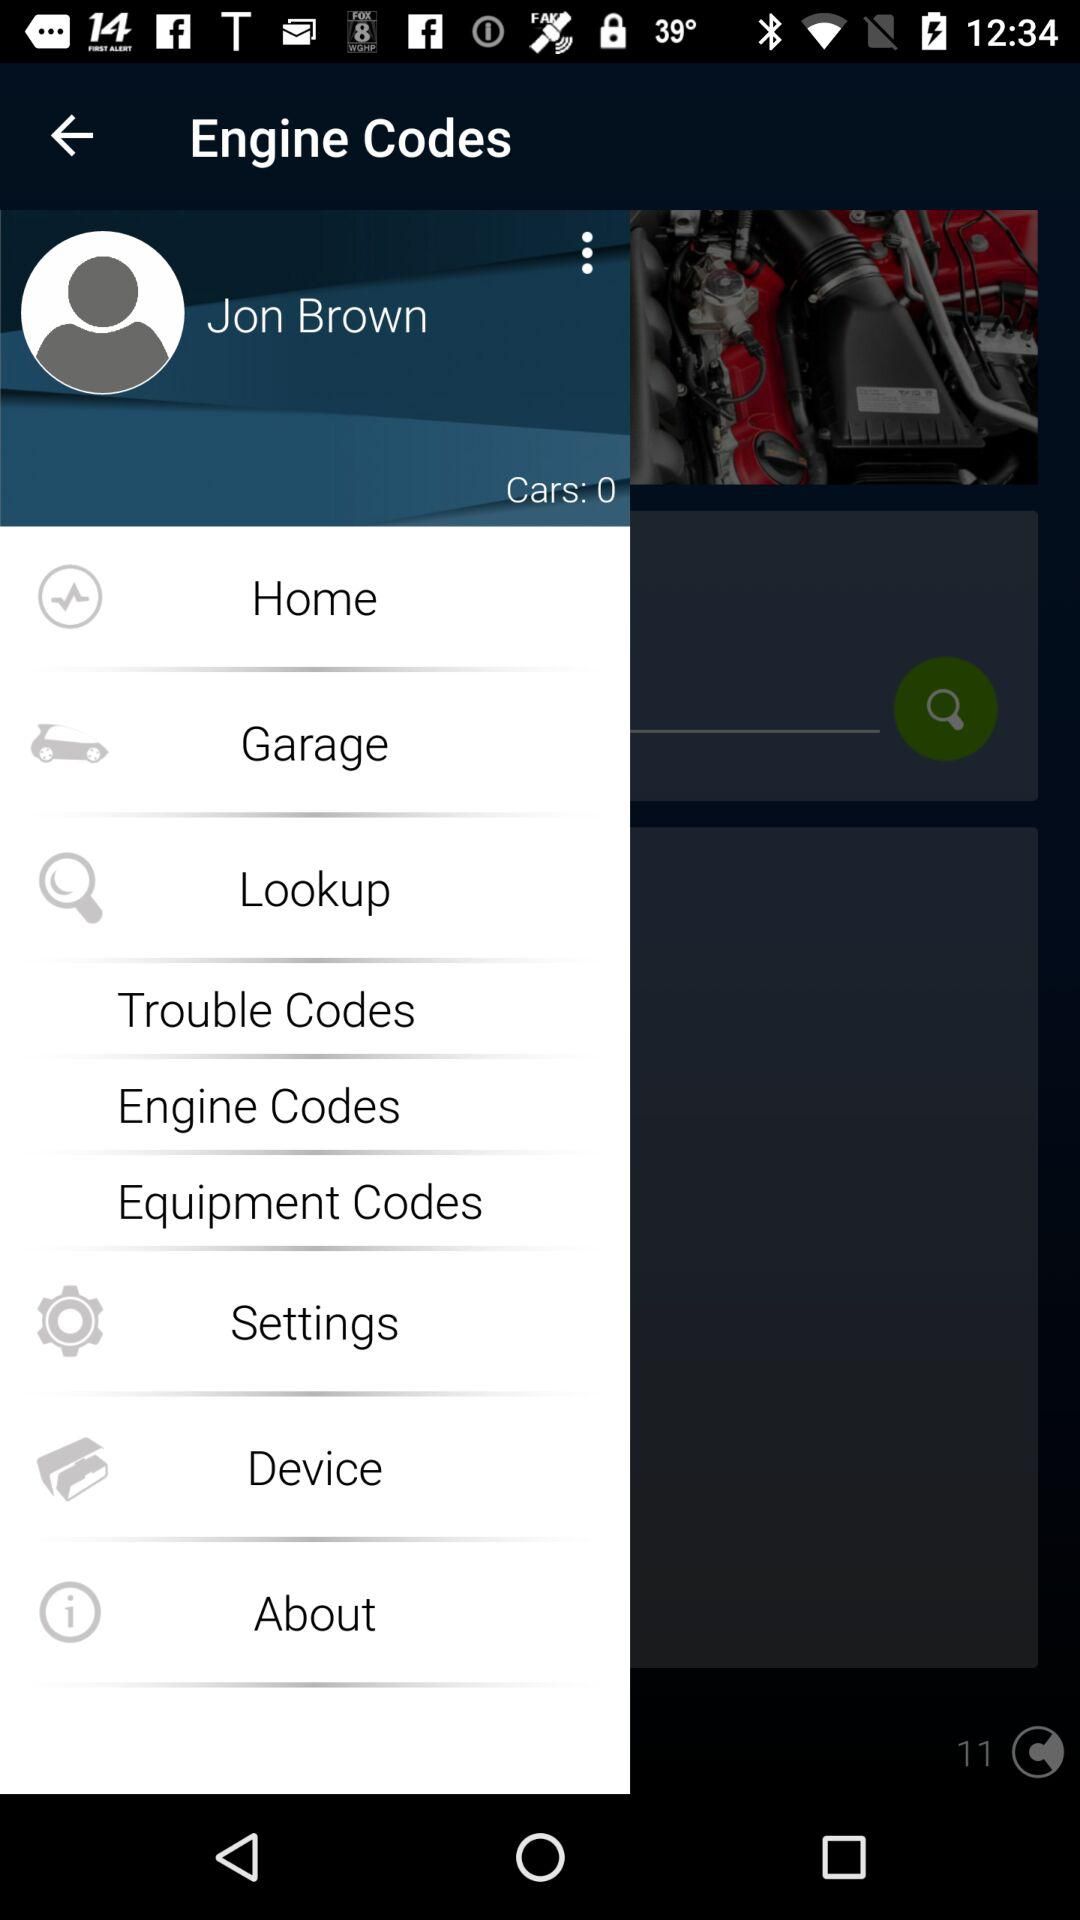What are the different types of codes given on the screen? The different types of codes given are "Trouble Codes", "Engine Codes" and "Equipment Codes". 